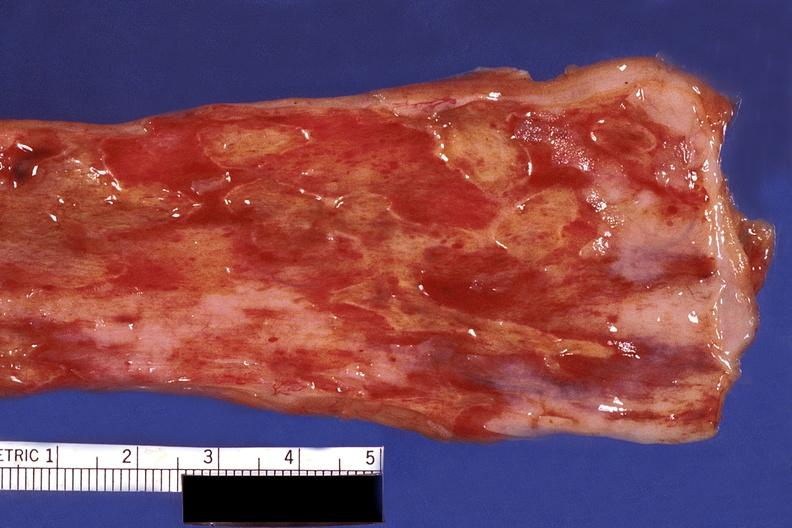s this photo of infant from head to toe present?
Answer the question using a single word or phrase. No 